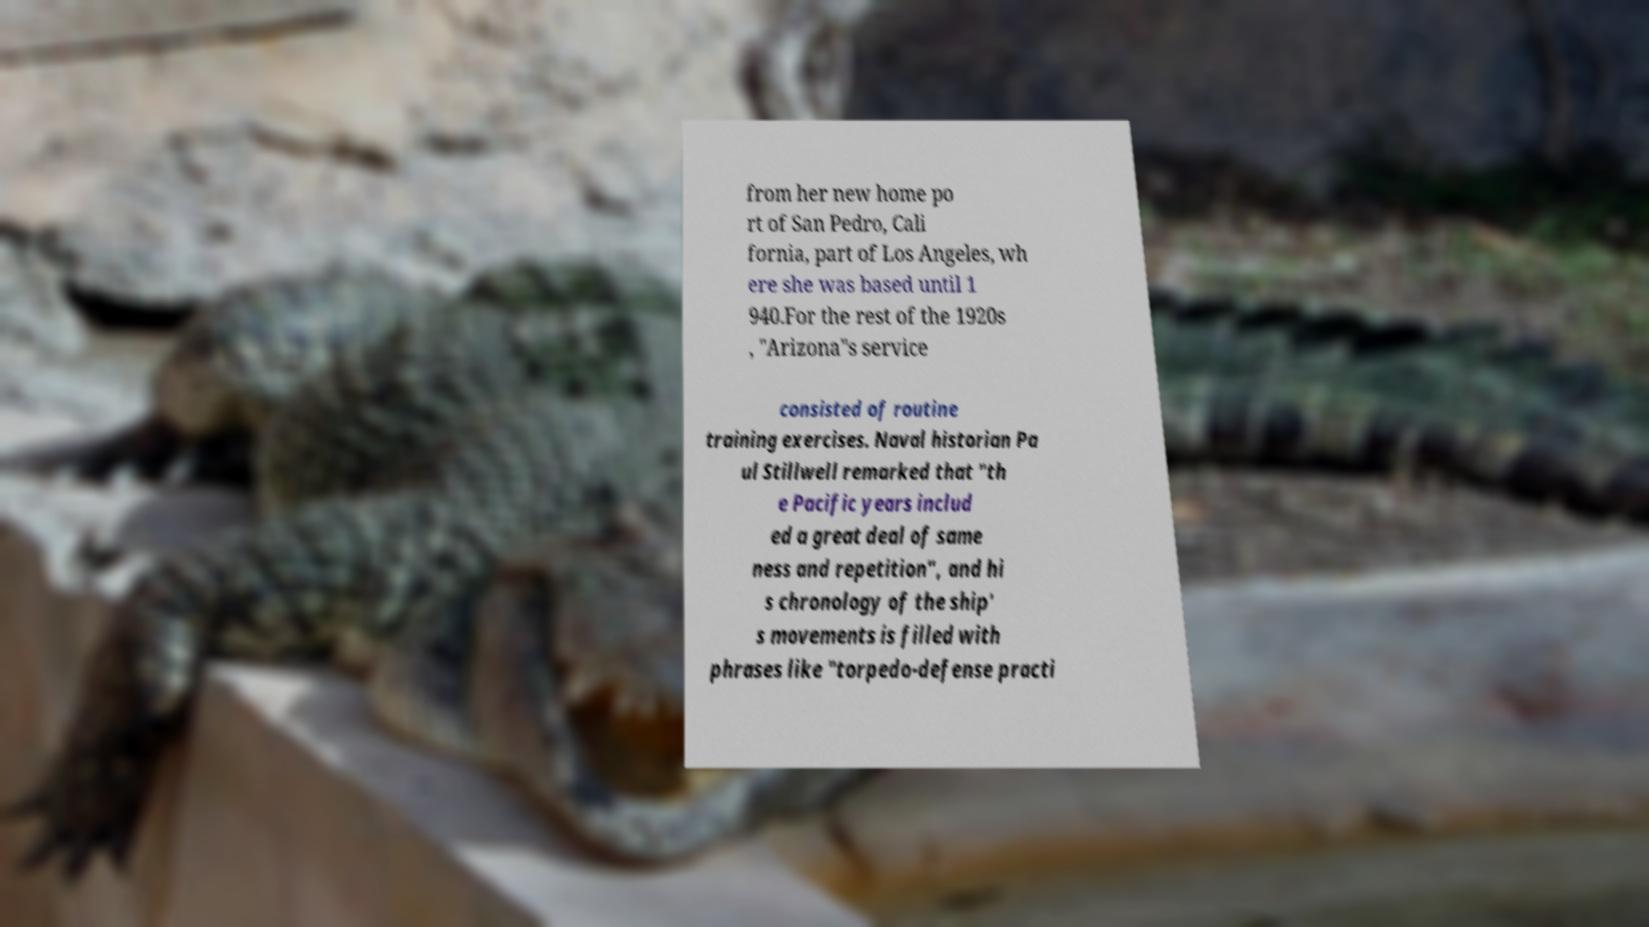There's text embedded in this image that I need extracted. Can you transcribe it verbatim? from her new home po rt of San Pedro, Cali fornia, part of Los Angeles, wh ere she was based until 1 940.For the rest of the 1920s , "Arizona"s service consisted of routine training exercises. Naval historian Pa ul Stillwell remarked that "th e Pacific years includ ed a great deal of same ness and repetition", and hi s chronology of the ship' s movements is filled with phrases like "torpedo-defense practi 